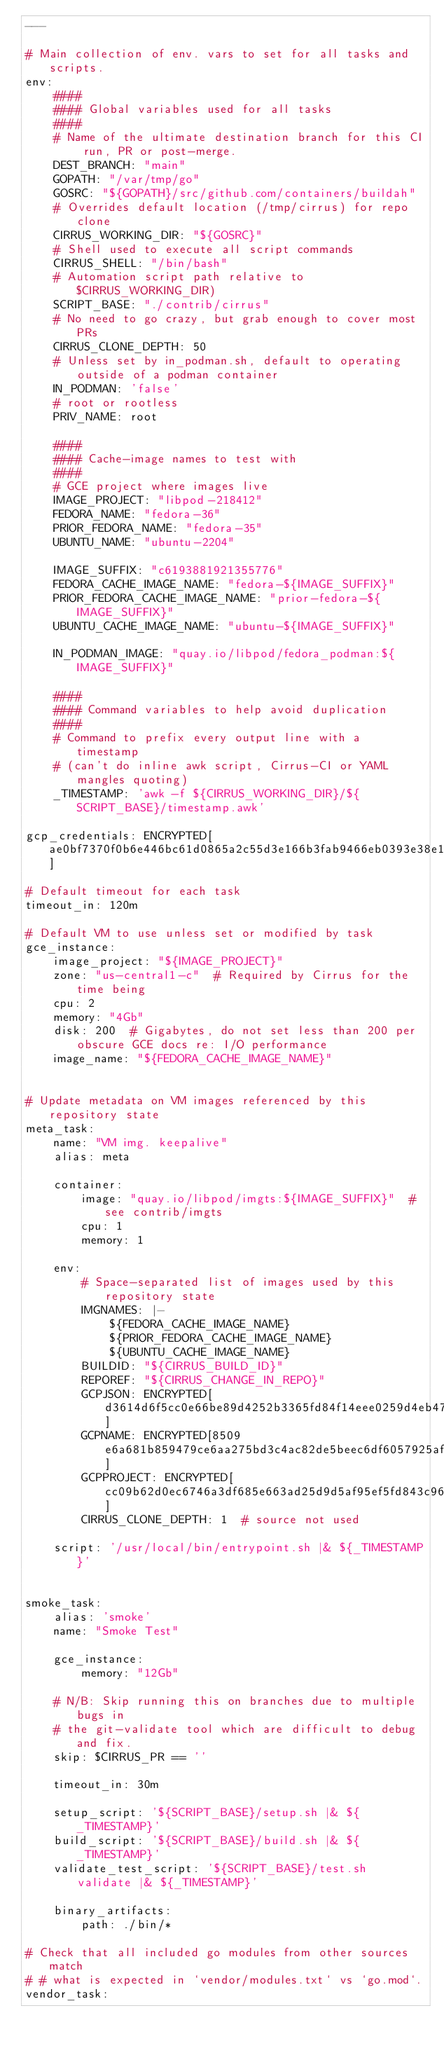Convert code to text. <code><loc_0><loc_0><loc_500><loc_500><_YAML_>---

# Main collection of env. vars to set for all tasks and scripts.
env:
    ####
    #### Global variables used for all tasks
    ####
    # Name of the ultimate destination branch for this CI run, PR or post-merge.
    DEST_BRANCH: "main"
    GOPATH: "/var/tmp/go"
    GOSRC: "${GOPATH}/src/github.com/containers/buildah"
    # Overrides default location (/tmp/cirrus) for repo clone
    CIRRUS_WORKING_DIR: "${GOSRC}"
    # Shell used to execute all script commands
    CIRRUS_SHELL: "/bin/bash"
    # Automation script path relative to $CIRRUS_WORKING_DIR)
    SCRIPT_BASE: "./contrib/cirrus"
    # No need to go crazy, but grab enough to cover most PRs
    CIRRUS_CLONE_DEPTH: 50
    # Unless set by in_podman.sh, default to operating outside of a podman container
    IN_PODMAN: 'false'
    # root or rootless
    PRIV_NAME: root

    ####
    #### Cache-image names to test with
    ####
    # GCE project where images live
    IMAGE_PROJECT: "libpod-218412"
    FEDORA_NAME: "fedora-36"
    PRIOR_FEDORA_NAME: "fedora-35"
    UBUNTU_NAME: "ubuntu-2204"

    IMAGE_SUFFIX: "c6193881921355776"
    FEDORA_CACHE_IMAGE_NAME: "fedora-${IMAGE_SUFFIX}"
    PRIOR_FEDORA_CACHE_IMAGE_NAME: "prior-fedora-${IMAGE_SUFFIX}"
    UBUNTU_CACHE_IMAGE_NAME: "ubuntu-${IMAGE_SUFFIX}"

    IN_PODMAN_IMAGE: "quay.io/libpod/fedora_podman:${IMAGE_SUFFIX}"

    ####
    #### Command variables to help avoid duplication
    ####
    # Command to prefix every output line with a timestamp
    # (can't do inline awk script, Cirrus-CI or YAML mangles quoting)
    _TIMESTAMP: 'awk -f ${CIRRUS_WORKING_DIR}/${SCRIPT_BASE}/timestamp.awk'

gcp_credentials: ENCRYPTED[ae0bf7370f0b6e446bc61d0865a2c55d3e166b3fab9466eb0393e38e1c66a31ca4c71ddc7e0139d47d075c36dd6d3fd7]

# Default timeout for each task
timeout_in: 120m

# Default VM to use unless set or modified by task
gce_instance:
    image_project: "${IMAGE_PROJECT}"
    zone: "us-central1-c"  # Required by Cirrus for the time being
    cpu: 2
    memory: "4Gb"
    disk: 200  # Gigabytes, do not set less than 200 per obscure GCE docs re: I/O performance
    image_name: "${FEDORA_CACHE_IMAGE_NAME}"


# Update metadata on VM images referenced by this repository state
meta_task:
    name: "VM img. keepalive"
    alias: meta

    container:
        image: "quay.io/libpod/imgts:${IMAGE_SUFFIX}"  # see contrib/imgts
        cpu: 1
        memory: 1

    env:
        # Space-separated list of images used by this repository state
        IMGNAMES: |-
            ${FEDORA_CACHE_IMAGE_NAME}
            ${PRIOR_FEDORA_CACHE_IMAGE_NAME}
            ${UBUNTU_CACHE_IMAGE_NAME}
        BUILDID: "${CIRRUS_BUILD_ID}"
        REPOREF: "${CIRRUS_CHANGE_IN_REPO}"
        GCPJSON: ENCRYPTED[d3614d6f5cc0e66be89d4252b3365fd84f14eee0259d4eb47e25fc0bc2842c7937f5ee8c882b7e547b4c5ec4b6733b14]
        GCPNAME: ENCRYPTED[8509e6a681b859479ce6aa275bd3c4ac82de5beec6df6057925afc4cd85b7ef2e879066ae8baaa2d453b82958e434578]
        GCPPROJECT: ENCRYPTED[cc09b62d0ec6746a3df685e663ad25d9d5af95ef5fd843c96f3d0ec9d7f065dc63216b9c685c9f43a776a1d403991494]
        CIRRUS_CLONE_DEPTH: 1  # source not used

    script: '/usr/local/bin/entrypoint.sh |& ${_TIMESTAMP}'


smoke_task:
    alias: 'smoke'
    name: "Smoke Test"

    gce_instance:
        memory: "12Gb"

    # N/B: Skip running this on branches due to multiple bugs in
    # the git-validate tool which are difficult to debug and fix.
    skip: $CIRRUS_PR == ''

    timeout_in: 30m

    setup_script: '${SCRIPT_BASE}/setup.sh |& ${_TIMESTAMP}'
    build_script: '${SCRIPT_BASE}/build.sh |& ${_TIMESTAMP}'
    validate_test_script: '${SCRIPT_BASE}/test.sh validate |& ${_TIMESTAMP}'

    binary_artifacts:
        path: ./bin/*

# Check that all included go modules from other sources match
# # what is expected in `vendor/modules.txt` vs `go.mod`.
vendor_task:</code> 